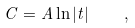<formula> <loc_0><loc_0><loc_500><loc_500>C = A \ln | t | \quad ,</formula> 